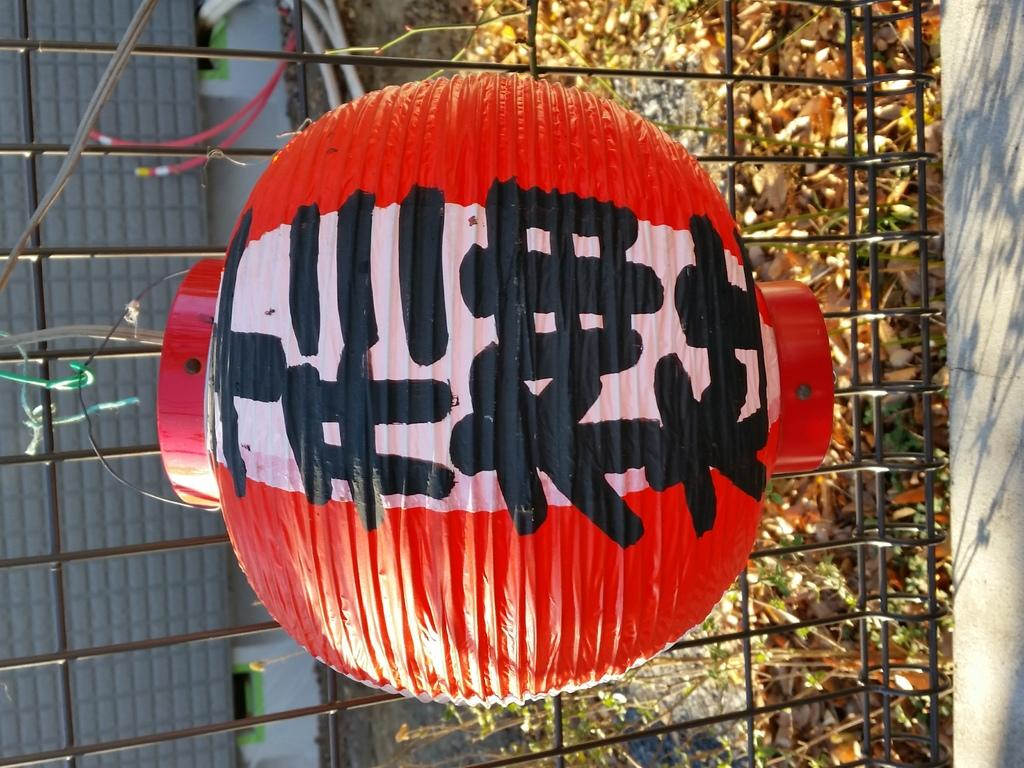What object is the main focus of the image? There is a Chinese lantern in the image. Can you describe the Chinese lantern in more detail? Something is written on the Chinese lantern. What can be seen in the background of the image? There are leaves and iron bars in the background of the image. What type of cork can be seen floating in the image? There is no cork present in the image. What kind of business is being conducted in the image? The image does not depict any business activity. 